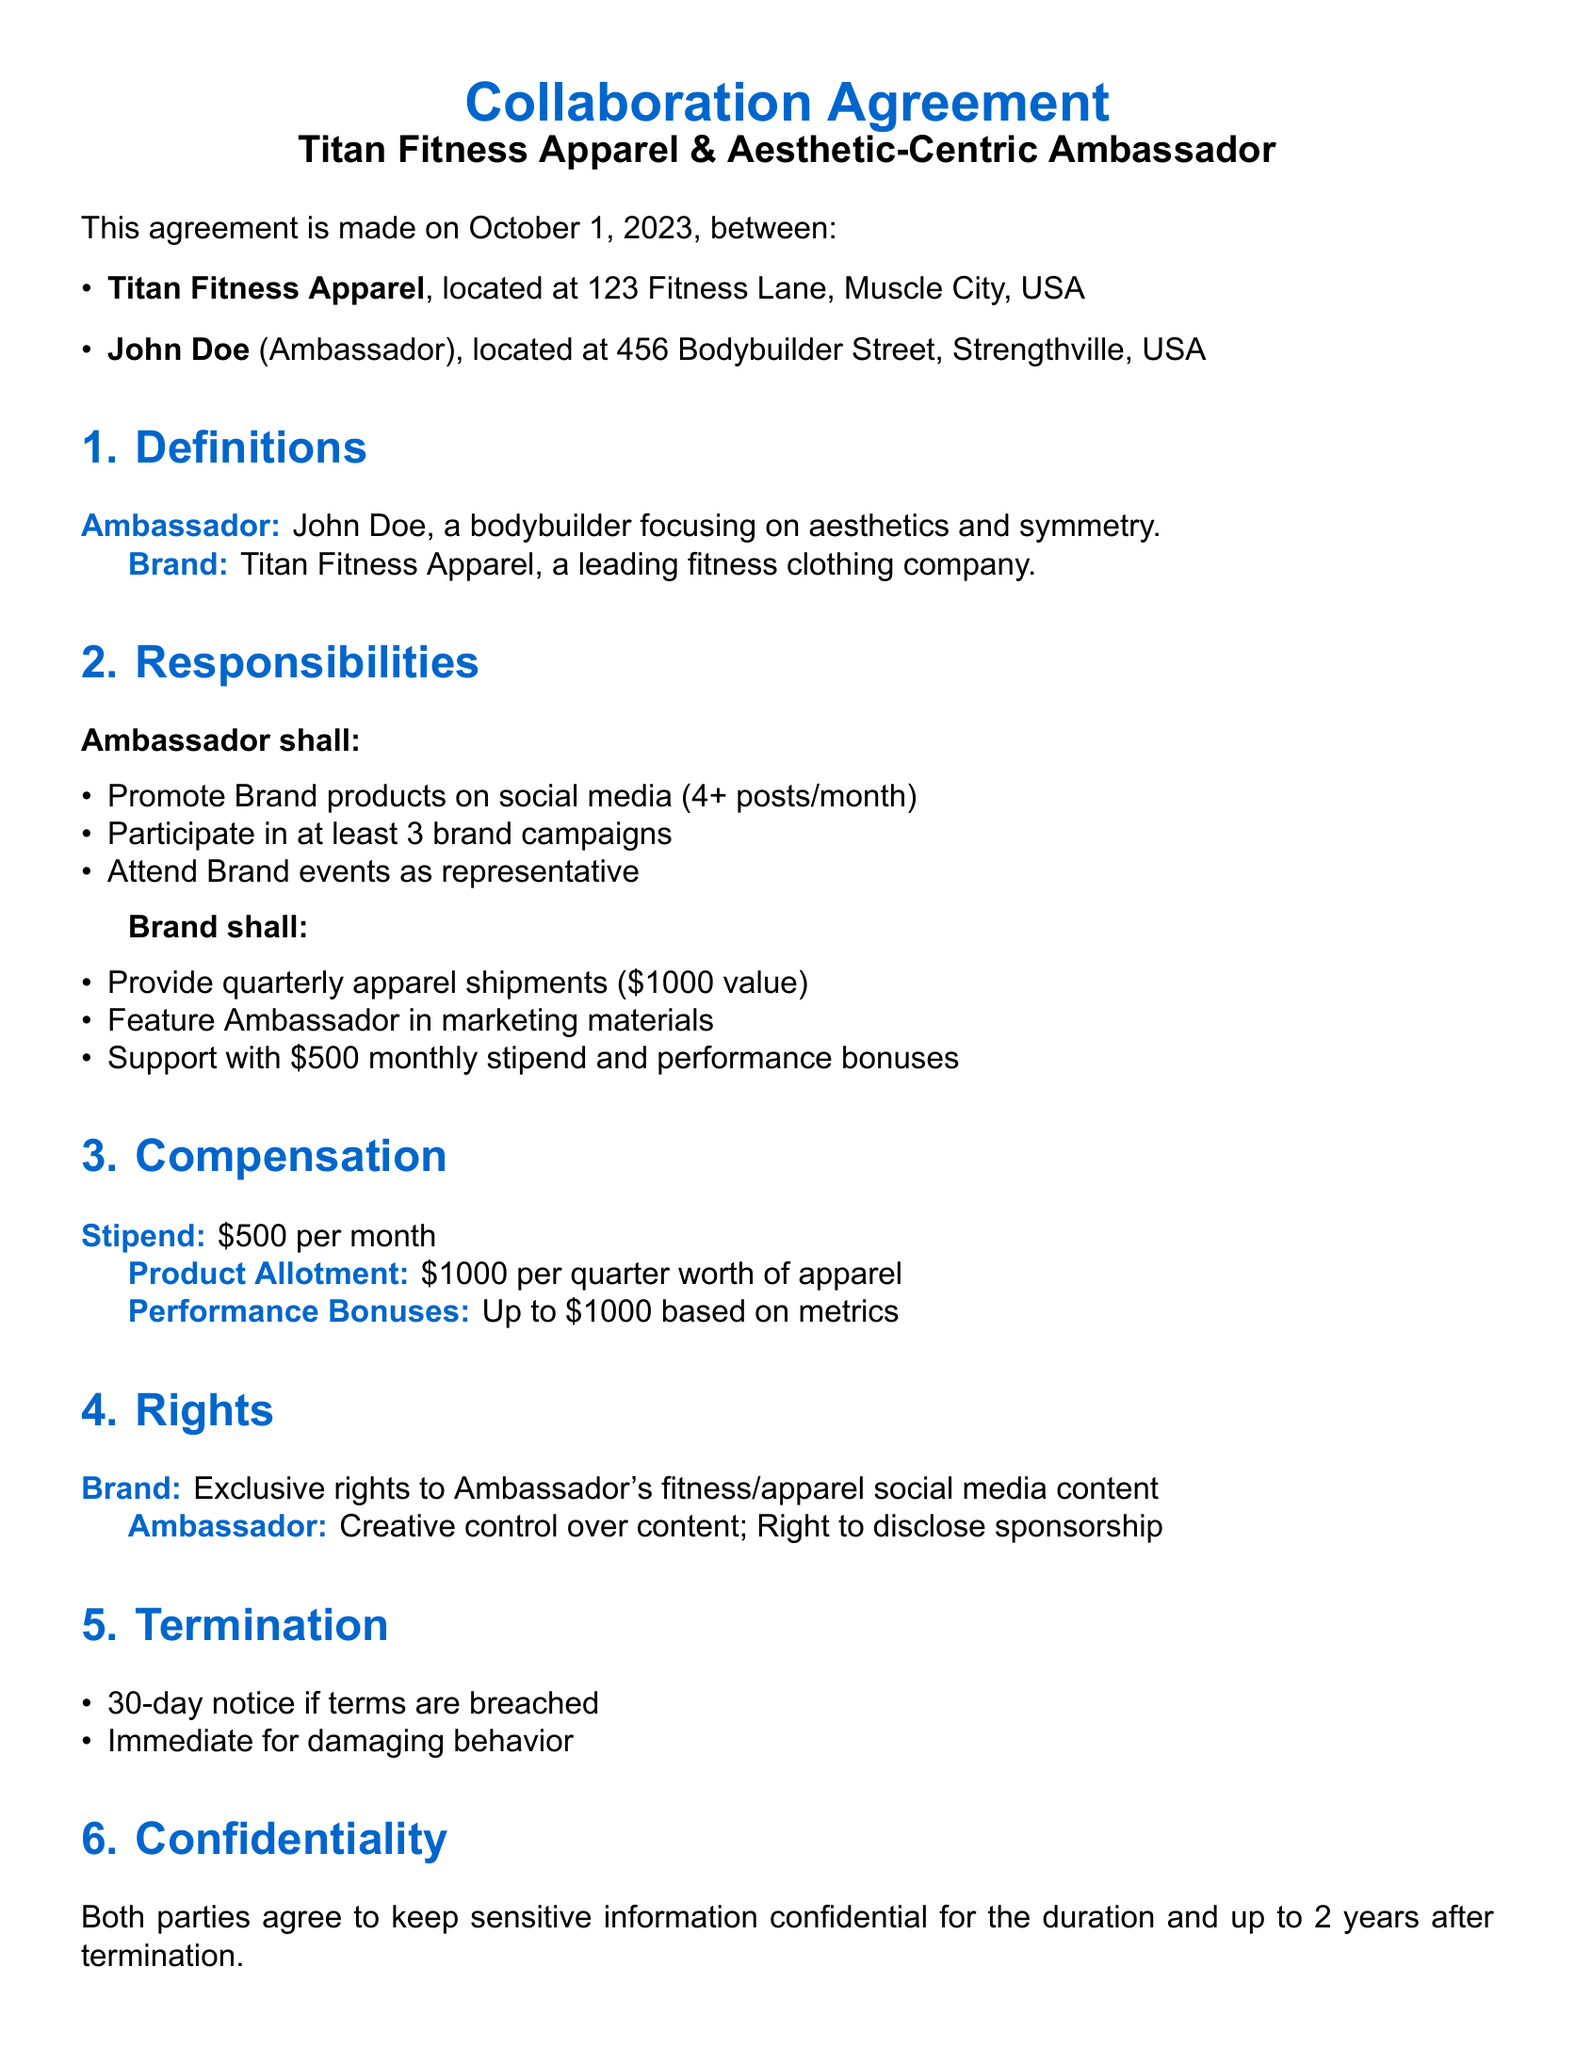What is the date of the agreement? The date of the agreement is explicitly stated in the document.
Answer: October 1, 2023 Who is the Ambassador? The Ambassador's name is mentioned in the document.
Answer: John Doe What is the value of the quarterly apparel shipments? The document specifies the total value of apparels provided quarterly.
Answer: $1000 How many brand campaigns must the Ambassador participate in? The required number of campaigns for participation is provided in the responsibilities.
Answer: 3 What is the monthly stipend provided to the Ambassador? The compensation for the Ambassador including stipends is included in the contract.
Answer: $500 What exclusive rights does the Brand have over the Ambassador's content? The rights given to the Brand regarding the Ambassador's content are elaborated upon.
Answer: Exclusive rights What is the notice period for termination due to breach of terms? The document details the required notice period for contract termination.
Answer: 30-day notice How long must sensitive information remain confidential? The duration for which confidentiality must be maintained is stated in the agreement.
Answer: 2 years In which state is this agreement governed? The governing law for the contract is mentioned in a specific section.
Answer: California 